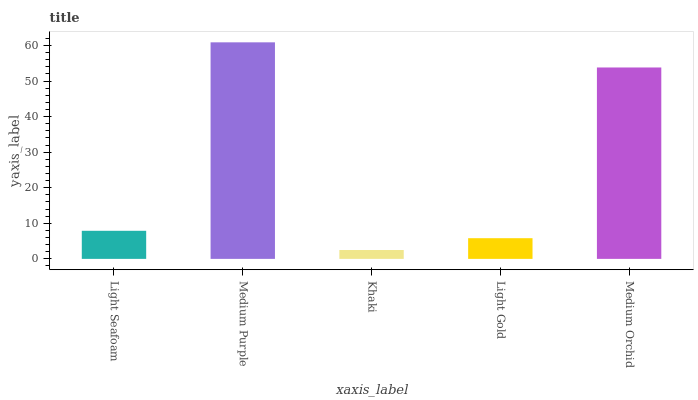Is Khaki the minimum?
Answer yes or no. Yes. Is Medium Purple the maximum?
Answer yes or no. Yes. Is Medium Purple the minimum?
Answer yes or no. No. Is Khaki the maximum?
Answer yes or no. No. Is Medium Purple greater than Khaki?
Answer yes or no. Yes. Is Khaki less than Medium Purple?
Answer yes or no. Yes. Is Khaki greater than Medium Purple?
Answer yes or no. No. Is Medium Purple less than Khaki?
Answer yes or no. No. Is Light Seafoam the high median?
Answer yes or no. Yes. Is Light Seafoam the low median?
Answer yes or no. Yes. Is Medium Orchid the high median?
Answer yes or no. No. Is Medium Purple the low median?
Answer yes or no. No. 